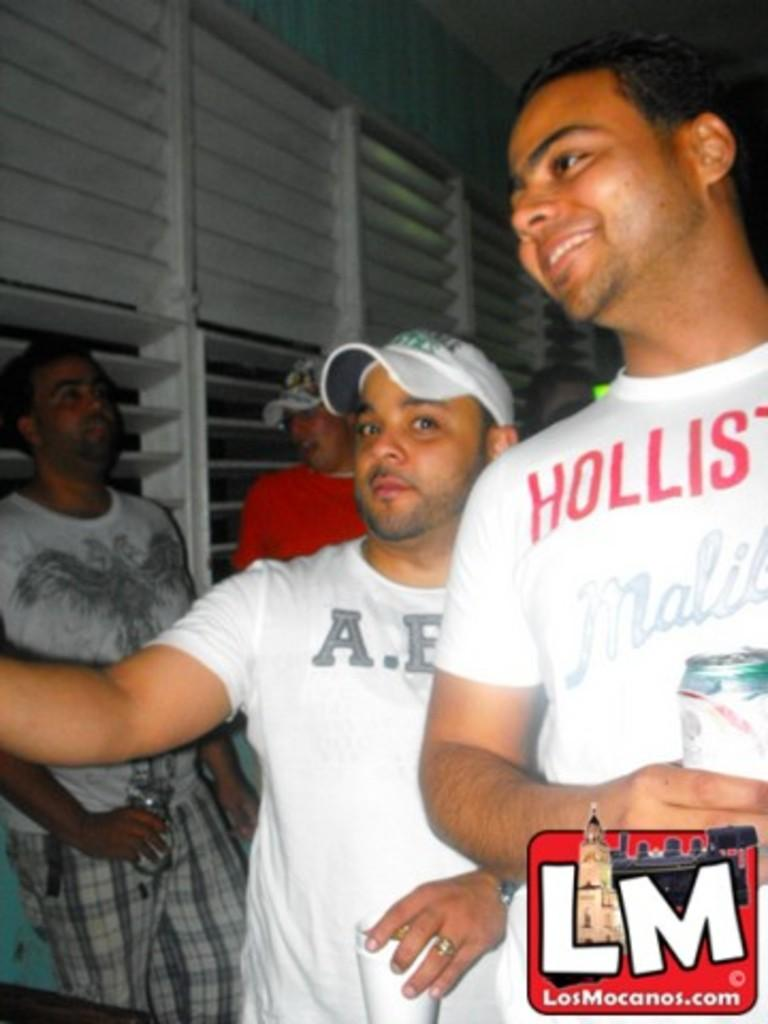What is happening in the image? There are people standing in the image. What can be seen in the background or surrounding the people? There are windows visible in the image. What type of bottle is being used as a weapon in the image? There is no bottle or weapon present in the image; it only shows people standing and windows. 